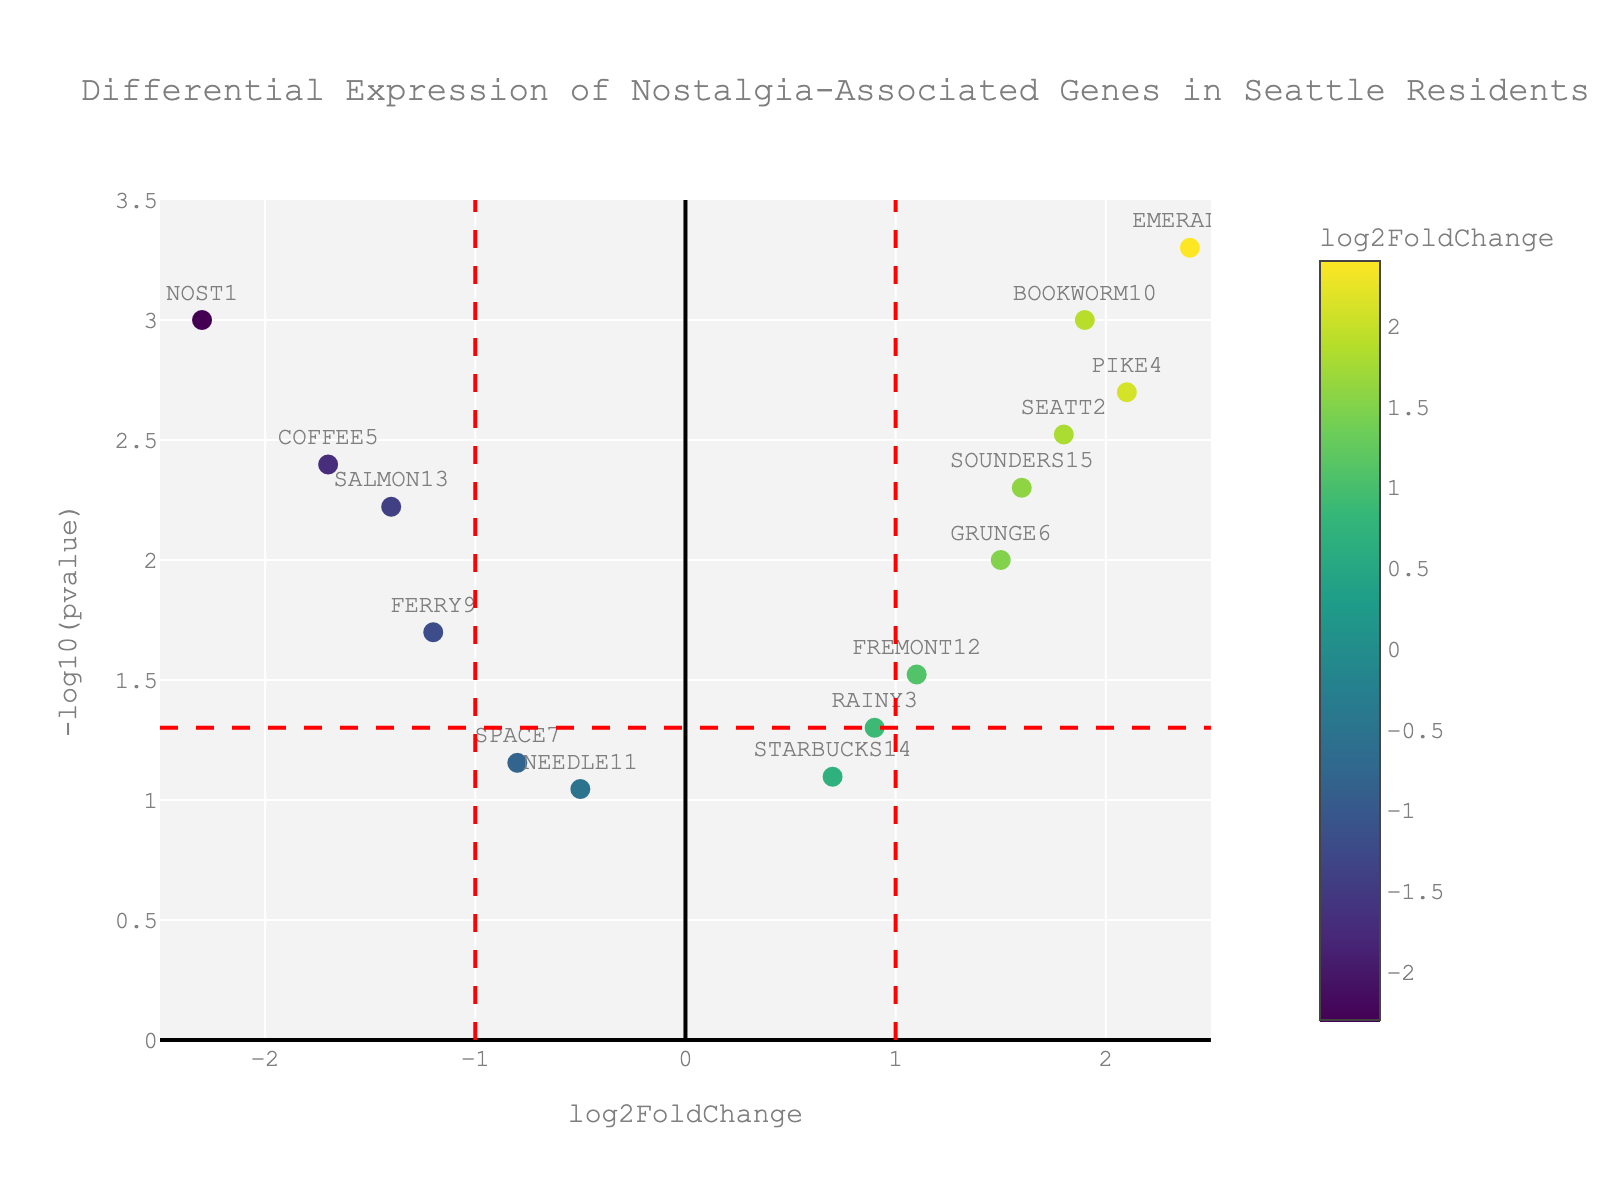Which gene has the highest log2FoldChange? To find the gene with the highest log2FoldChange, look at the x-axis for the point with the furthest right position. The gene labeled "EMERALD8" has the highest log2FoldChange.
Answer: EMERALD8 Which genes have p-values less than 0.005? P-values less than 0.005 correspond to y-values greater than -log10(0.005) on the y-axis. The genes above this threshold are "NOST1", "SEATT2", "PIKE4", "COFFEE5", "EMERALD8", "BOOKWORM10", and "SOUNDERS15".
Answer: NOST1, SEATT2, PIKE4, COFFEE5, EMERALD8, BOOKWORM10, SOUNDERS15 How many genes are significantly upregulated (log2FoldChange > 1 and p-value < 0.05)? Upregulated genes have log2FoldChange > 1 and p-values corresponding to y-values above -log10(0.05). The genes meeting these criteria are "SEATT2", "PIKE4", "EMERALD8", "BOOKWORM10", "GRUNGE6", and "SOUNDERS15". There are 6 such genes.
Answer: 6 Which gene has the most negative log2FoldChange? To find the gene with the most negative log2FoldChange, look at the x-axis for the point furthest to the left. The gene labeled "NOST1" has the most negative log2FoldChange.
Answer: NOST1 Which genes lie within the threshold of log2FoldChange between -1 and 1 but have a significant p-value (< 0.05)? Genes within the log2FoldChange range of -1 to 1 are between the vertical red lines. Significant p-values correspond to y-values above -log10(0.05). The genes within these criteria are "RAINY3", "FREMONT12", and "SALMON13".
Answer: RAINY3, FREMONT12, SALMON13 